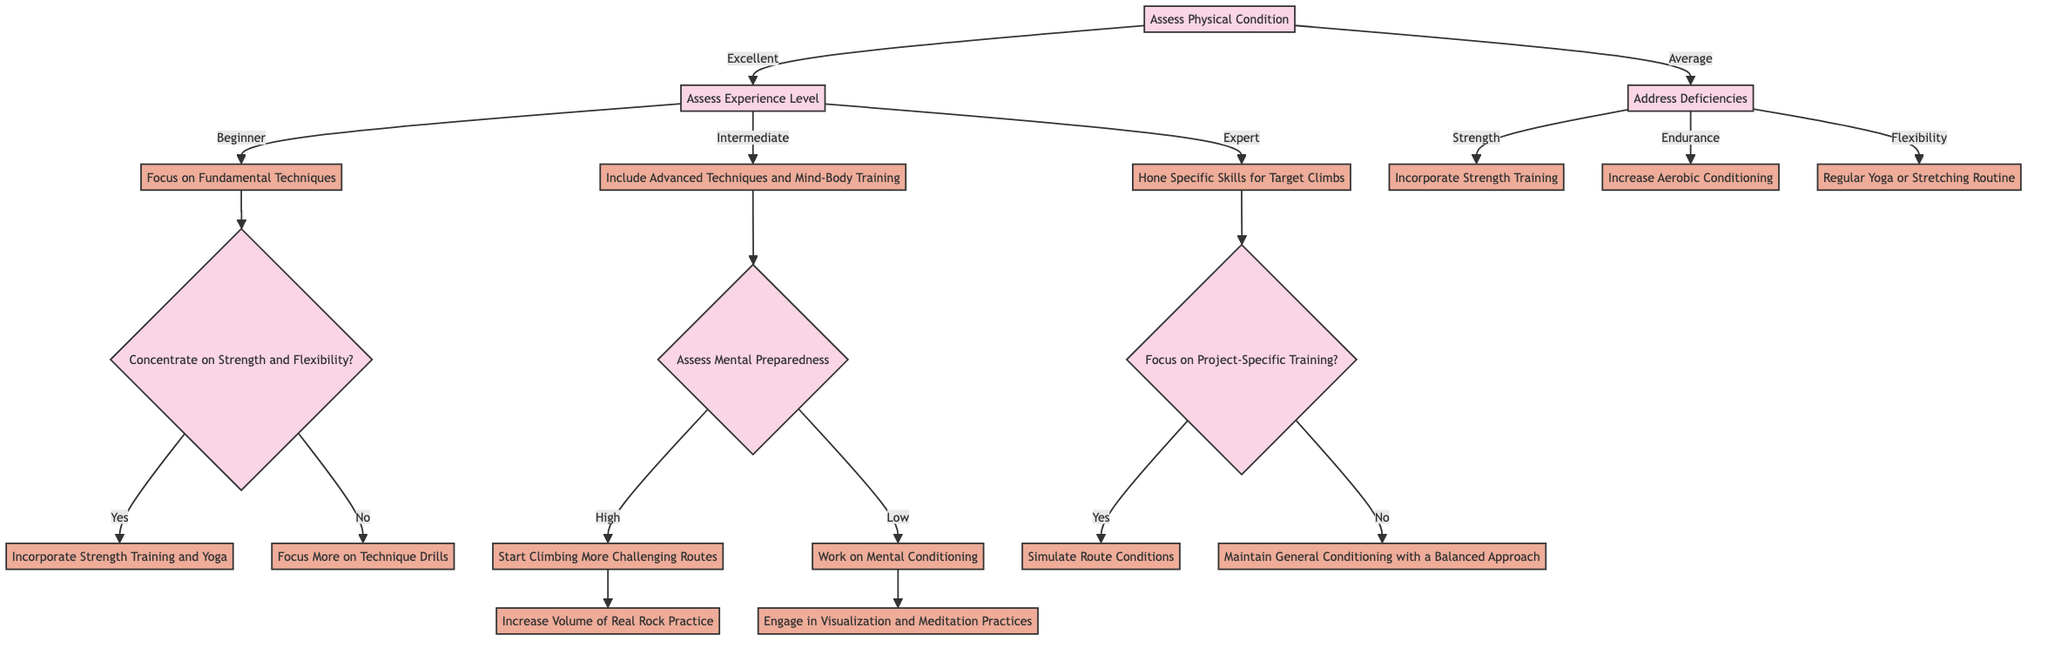What is the first question asked in the decision tree? The diagram begins with "Assess Physical Condition" which is the initial question before branching out into different options.
Answer: Assess Physical Condition How many options are available after assessing physical condition? From the node "Assess Physical Condition", there are two options: "Excellent" and "Average". Therefore, there are a total of 2 options available at this node.
Answer: 2 What action is suggested for an intermediate climber? For an intermediate climber, the action is to "Include Advanced Techniques and Mind-Body Training" which is clearly stated under the experience level section of the diagram.
Answer: Include Advanced Techniques and Mind-Body Training If a climber is at the beginner level, what is their first action? The first action for a beginner climber is to "Focus on Fundamental Techniques," as indicated immediately after assessing their experience level.
Answer: Focus on Fundamental Techniques What happens if a climber's mental preparedness is assessed as high? If a climber's mental preparedness is assessed as high, the next action is to "Start Climbing More Challenging Routes" according to the diagram's flow from the mental preparedness evaluation.
Answer: Start Climbing More Challenging Routes What specific training focus is necessary for expert climbers? Expert climbers should "Hone Specific Skills for Target Climbs," which is clearly defined in the action section for that experience level in the decision tree.
Answer: Hone Specific Skills for Target Climbs Is there a step addressing deficiency in strength for average climbers? Yes, the action for addressing strength deficiency for average climbers is to "Incorporate Strength Training," which is specified as one of the options available under the average category.
Answer: Incorporate Strength Training What is the next step after the action for a beginner focused on strength and flexibility? After focusing on strength and flexibility, the next step involves a question: "Concentrate on Strength and Flexibility?" where the answers lead to different actions, either incorporating strength training and yoga or focusing more on technique drills.
Answer: Concentrate on Strength and Flexibility? What does the decision tree recommend for addressing flexibility issues in average climbers? For addressing flexibility issues, the recommendation in the diagram is to have a "Regular Yoga or Stretching Routine," which is one of the specific actions listed under the average category.
Answer: Regular Yoga or Stretching Routine 